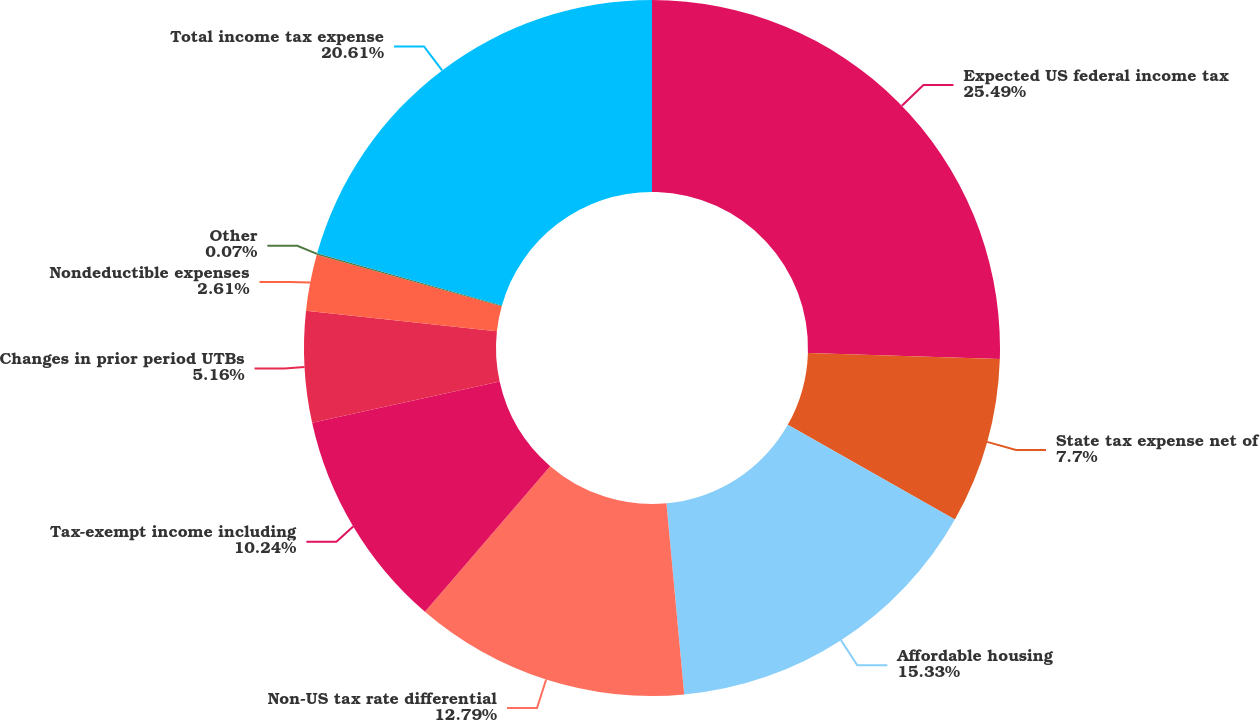Convert chart to OTSL. <chart><loc_0><loc_0><loc_500><loc_500><pie_chart><fcel>Expected US federal income tax<fcel>State tax expense net of<fcel>Affordable housing<fcel>Non-US tax rate differential<fcel>Tax-exempt income including<fcel>Changes in prior period UTBs<fcel>Nondeductible expenses<fcel>Other<fcel>Total income tax expense<nl><fcel>25.5%<fcel>7.7%<fcel>15.33%<fcel>12.79%<fcel>10.24%<fcel>5.16%<fcel>2.61%<fcel>0.07%<fcel>20.61%<nl></chart> 